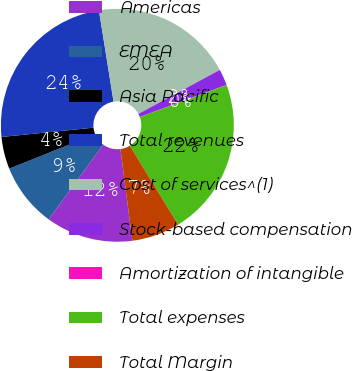Convert chart. <chart><loc_0><loc_0><loc_500><loc_500><pie_chart><fcel>Americas<fcel>EMEA<fcel>Asia Pacific<fcel>Total revenues<fcel>Cost of services^(1)<fcel>Stock-based compensation<fcel>Amortization of intangible<fcel>Total expenses<fcel>Total Margin<nl><fcel>12.1%<fcel>8.89%<fcel>4.47%<fcel>24.07%<fcel>19.64%<fcel>2.25%<fcel>0.04%<fcel>21.85%<fcel>6.68%<nl></chart> 